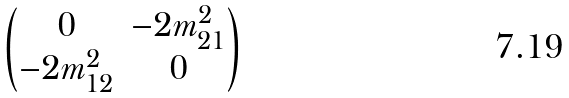<formula> <loc_0><loc_0><loc_500><loc_500>\begin{pmatrix} 0 & - 2 m ^ { 2 } _ { 2 1 } \\ - 2 m ^ { 2 } _ { 1 2 } & 0 \\ \end{pmatrix}</formula> 